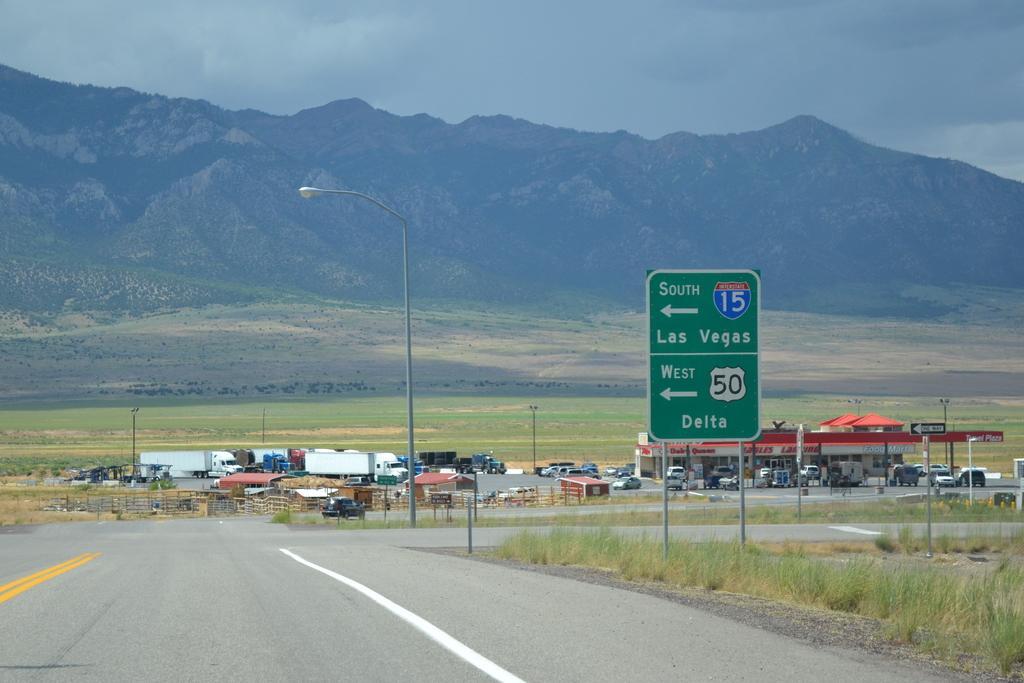Can you describe this image briefly? In this image on the right side there is grass on the ground and there is a board with some text written on it. In the background there are cars, poles and there is a building and there are mountains and the sky is cloudy. 